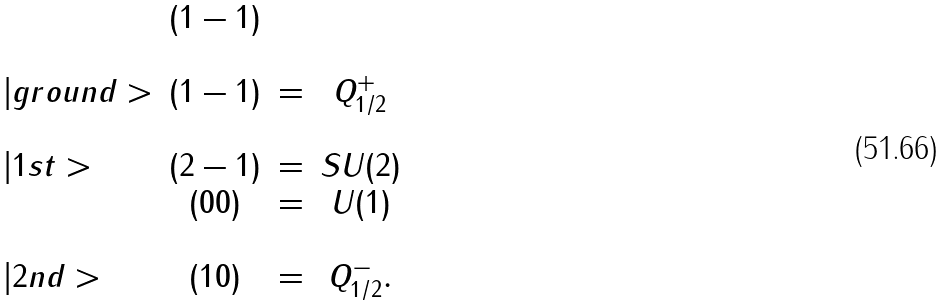Convert formula to latex. <formula><loc_0><loc_0><loc_500><loc_500>\begin{array} { l c c c } & ( 1 - 1 ) \\ \\ | g r o u n d > & ( 1 - 1 ) & = & Q _ { 1 / 2 } ^ { + } \\ \\ | 1 s t > & ( 2 - 1 ) & = & S U ( 2 ) \\ & ( 0 0 ) & = & U ( 1 ) \\ \\ | 2 n d > & ( 1 0 ) & = & Q _ { 1 / 2 } ^ { - } . \\ \end{array}</formula> 